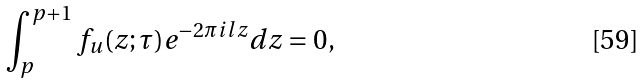<formula> <loc_0><loc_0><loc_500><loc_500>\int _ { p } ^ { p + 1 } f _ { u } ( z ; \tau ) e ^ { - 2 \pi i l z } d z = 0 ,</formula> 